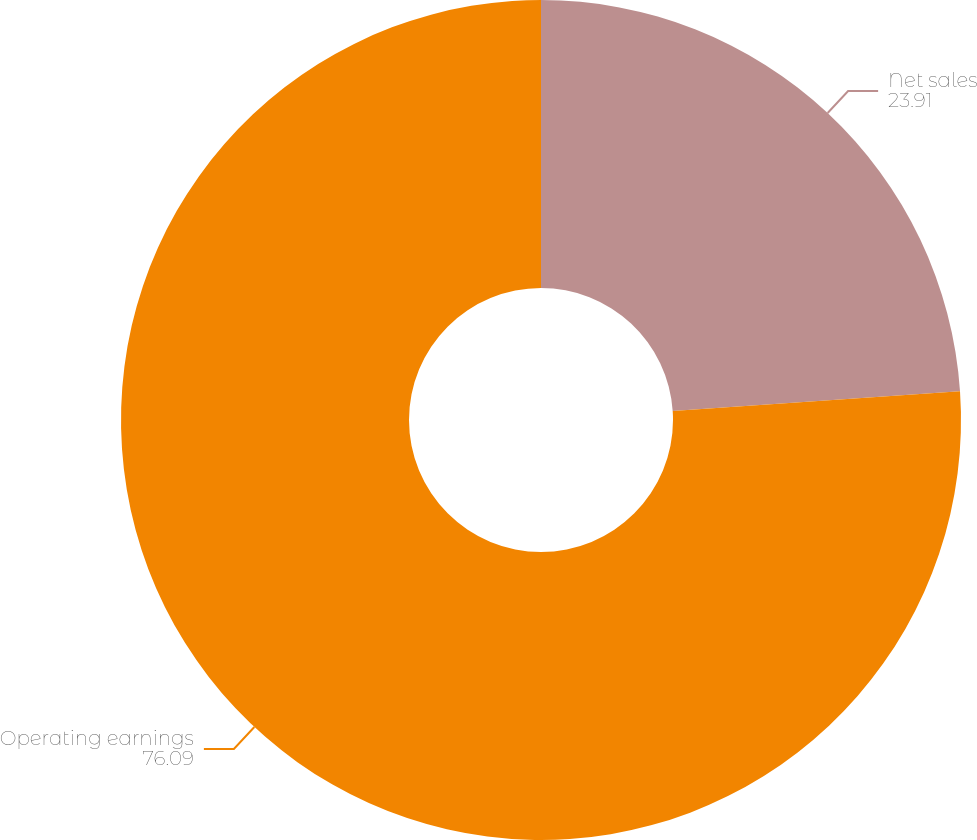Convert chart. <chart><loc_0><loc_0><loc_500><loc_500><pie_chart><fcel>Net sales<fcel>Operating earnings<nl><fcel>23.91%<fcel>76.09%<nl></chart> 